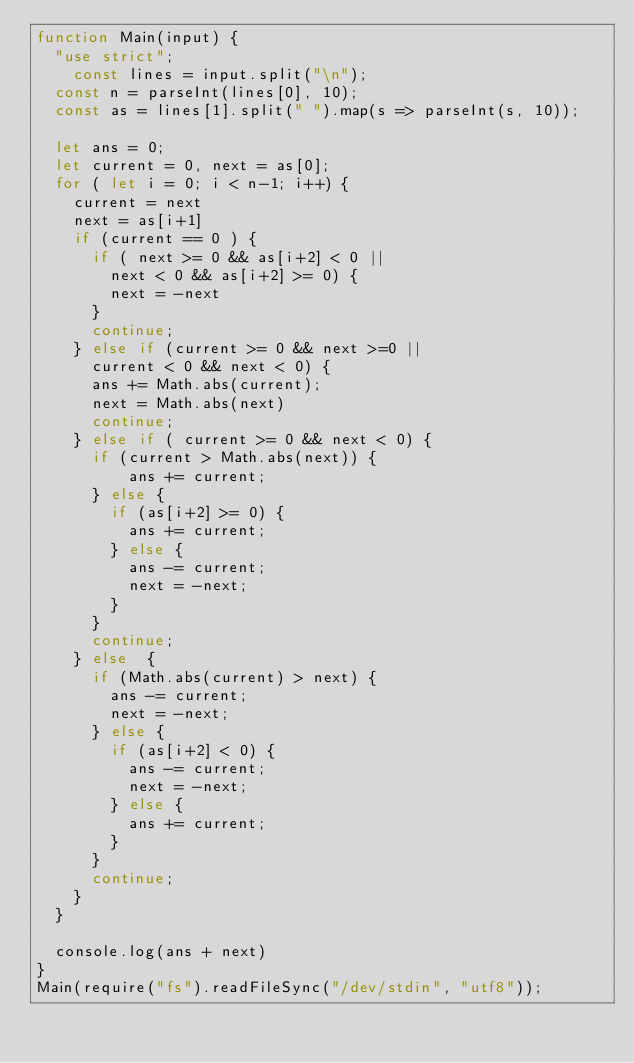Convert code to text. <code><loc_0><loc_0><loc_500><loc_500><_JavaScript_>function Main(input) {
  "use strict";
	const lines = input.split("\n");
  const n = parseInt(lines[0], 10);
  const as = lines[1].split(" ").map(s => parseInt(s, 10));

  let ans = 0;
  let current = 0, next = as[0];
  for ( let i = 0; i < n-1; i++) {
    current = next
    next = as[i+1]
    if (current == 0 ) {
      if ( next >= 0 && as[i+2] < 0 ||
        next < 0 && as[i+2] >= 0) {
        next = -next
      }
      continue;
    } else if (current >= 0 && next >=0 ||
      current < 0 && next < 0) {
      ans += Math.abs(current);
      next = Math.abs(next)
      continue;
    } else if ( current >= 0 && next < 0) {
      if (current > Math.abs(next)) {
          ans += current;
      } else {
        if (as[i+2] >= 0) {
          ans += current;
        } else {
          ans -= current;
          next = -next;
        }
      }
      continue;
    } else  {
      if (Math.abs(current) > next) {
        ans -= current;
        next = -next;
      } else {
        if (as[i+2] < 0) {
          ans -= current;
          next = -next;
        } else {
          ans += current;
        }
      }
      continue;
    }
  }
    
  console.log(ans + next)
}
Main(require("fs").readFileSync("/dev/stdin", "utf8"));</code> 